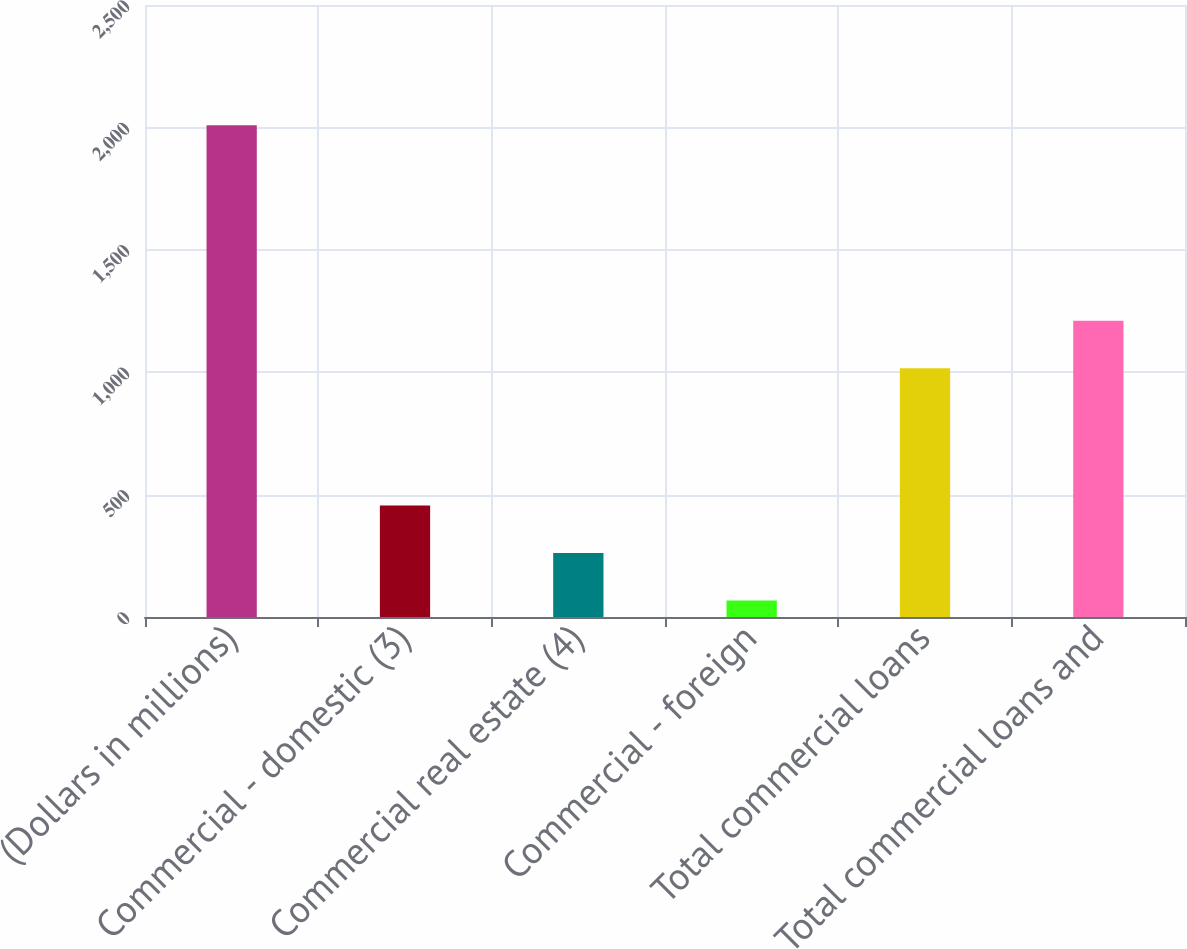Convert chart. <chart><loc_0><loc_0><loc_500><loc_500><bar_chart><fcel>(Dollars in millions)<fcel>Commercial - domestic (3)<fcel>Commercial real estate (4)<fcel>Commercial - foreign<fcel>Total commercial loans<fcel>Total commercial loans and<nl><fcel>2009<fcel>455.4<fcel>261.2<fcel>67<fcel>1016<fcel>1210.2<nl></chart> 